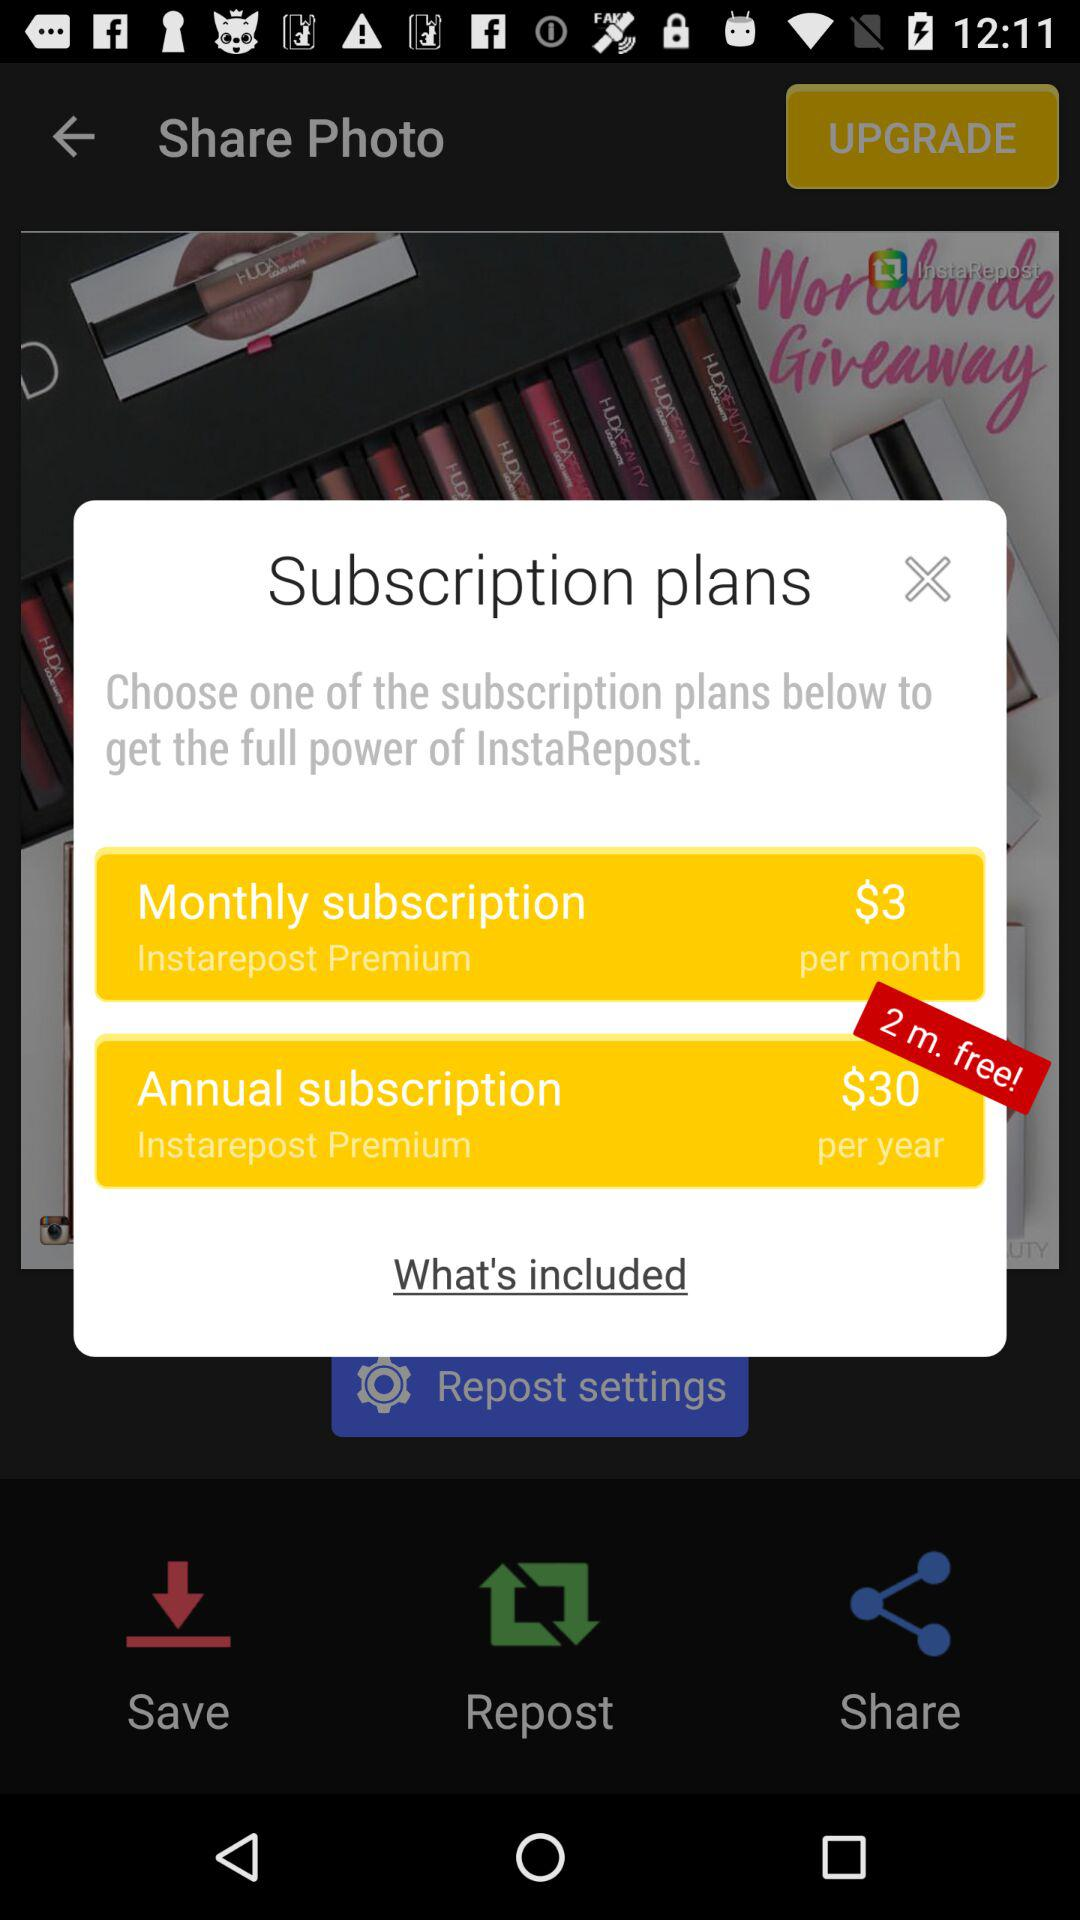What is the "Annual subscription" charge? The charge is $30. 